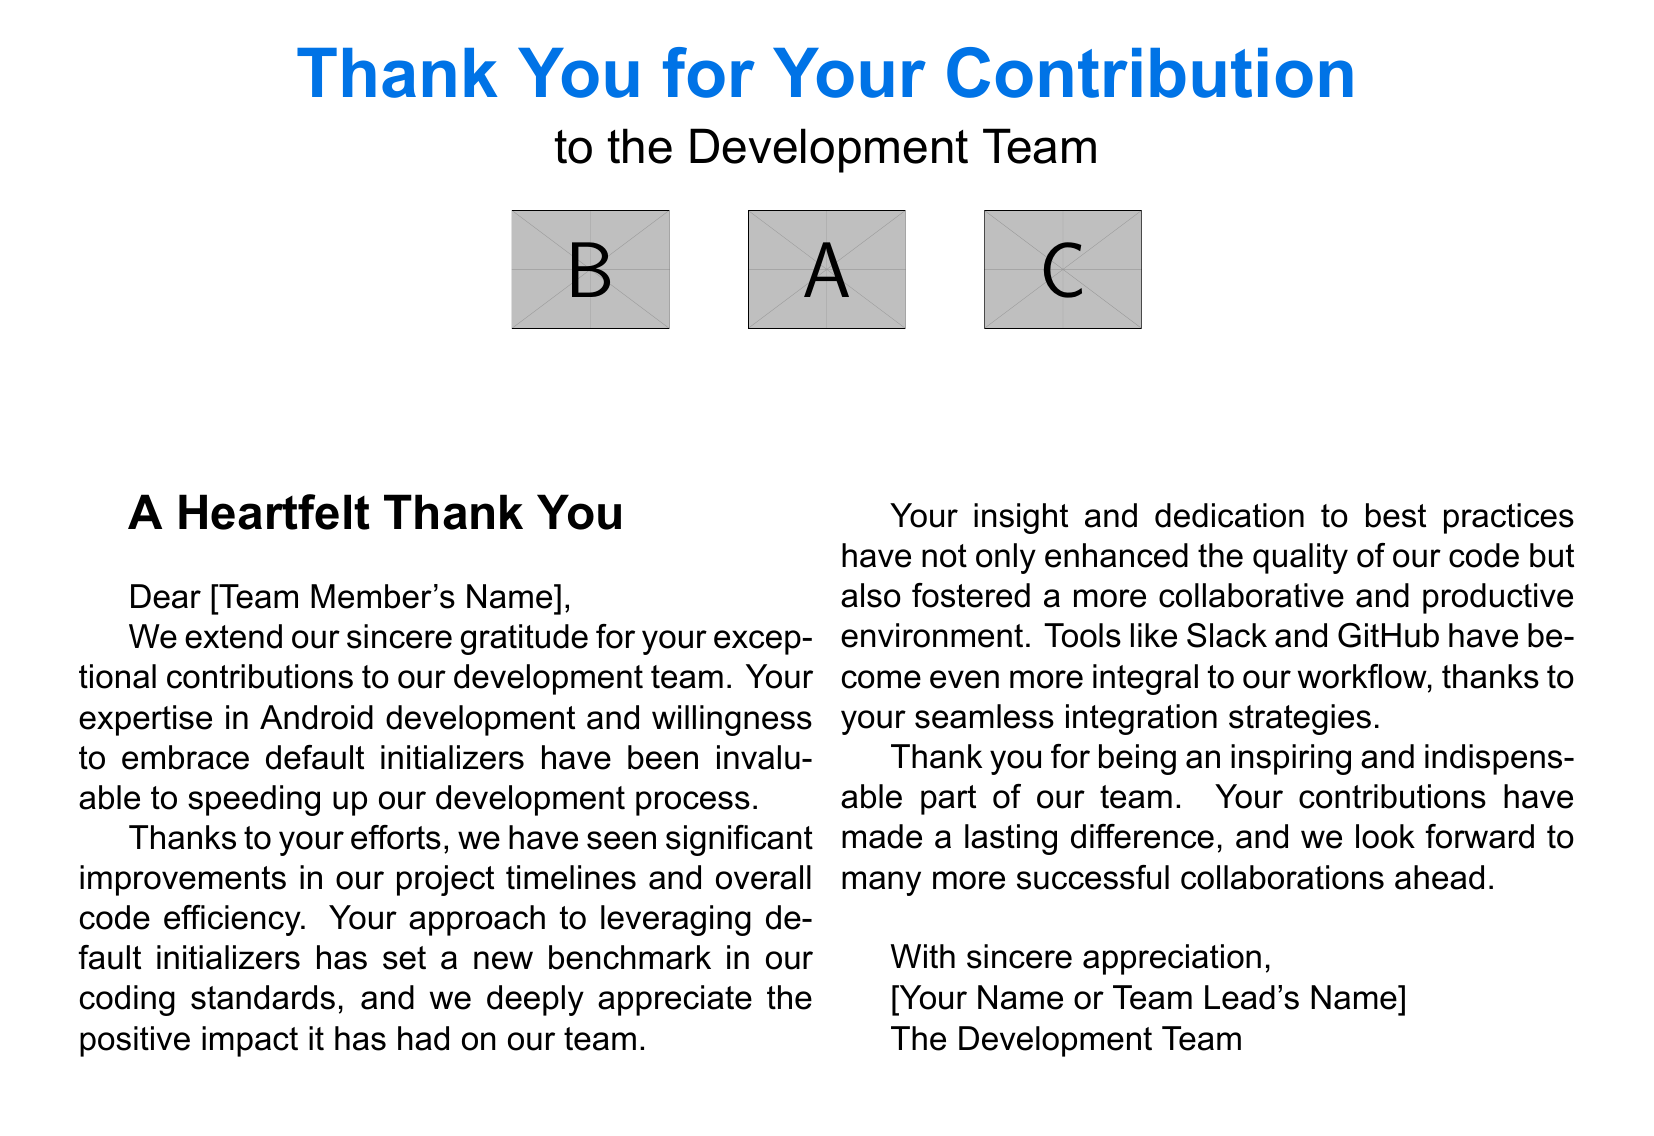What is the title of the card? The title is prominently displayed at the top of the card, stating "Thank You for Your Contribution."
Answer: Thank You for Your Contribution Who is the card addressed to? The card includes a placeholder for the recipient's name, "Dear [Team Member's Name]."
Answer: [Team Member's Name] What color is used for the main title? The main title is specifically colored using a defined color, which is "androidblue."
Answer: androidblue What does the card express gratitude for? The card mentions gratitude for "exceptional contributions to our development team."
Answer: exceptional contributions to our development team Which tools are mentioned in relation to collaboration? The card references "Slack and GitHub" as integral tools for workflow enhancement.
Answer: Slack and GitHub How has the recipient's approach impacted the project timelines? The card states that the recipient's contributions have led to "significant improvements in our project timelines."
Answer: significant improvements What has the recipient's contribution set a new benchmark for? It mentions that the recipient's use of default initializers has set a "new benchmark in our coding standards."
Answer: new benchmark in our coding standards What is the tone of the note inside the card? The tone of the note is described as "heartfelt" and expresses sincere appreciation.
Answer: heartfelt What is included in the visual design of the card? The card features icons of "collaboration tools and code" in its minimalist design.
Answer: collaboration tools and code 